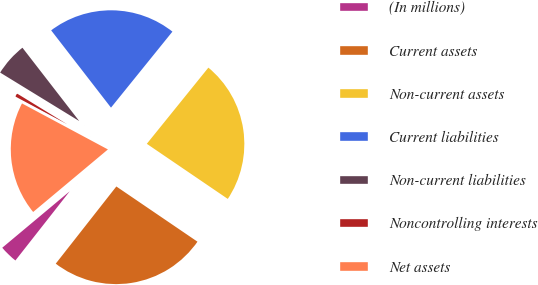Convert chart. <chart><loc_0><loc_0><loc_500><loc_500><pie_chart><fcel>(In millions)<fcel>Current assets<fcel>Non-current assets<fcel>Current liabilities<fcel>Non-current liabilities<fcel>Noncontrolling interests<fcel>Net assets<nl><fcel>3.32%<fcel>26.08%<fcel>23.69%<fcel>21.3%<fcel>5.76%<fcel>0.93%<fcel>18.91%<nl></chart> 